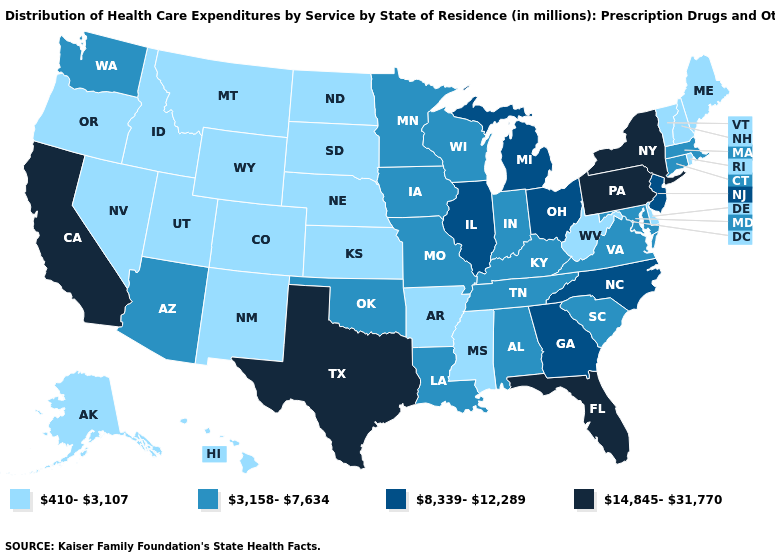Does Pennsylvania have a higher value than Alaska?
Quick response, please. Yes. Does Nevada have the same value as Kansas?
Write a very short answer. Yes. Among the states that border Idaho , which have the highest value?
Short answer required. Washington. What is the lowest value in states that border Vermont?
Short answer required. 410-3,107. Name the states that have a value in the range 3,158-7,634?
Concise answer only. Alabama, Arizona, Connecticut, Indiana, Iowa, Kentucky, Louisiana, Maryland, Massachusetts, Minnesota, Missouri, Oklahoma, South Carolina, Tennessee, Virginia, Washington, Wisconsin. Name the states that have a value in the range 410-3,107?
Quick response, please. Alaska, Arkansas, Colorado, Delaware, Hawaii, Idaho, Kansas, Maine, Mississippi, Montana, Nebraska, Nevada, New Hampshire, New Mexico, North Dakota, Oregon, Rhode Island, South Dakota, Utah, Vermont, West Virginia, Wyoming. Name the states that have a value in the range 3,158-7,634?
Keep it brief. Alabama, Arizona, Connecticut, Indiana, Iowa, Kentucky, Louisiana, Maryland, Massachusetts, Minnesota, Missouri, Oklahoma, South Carolina, Tennessee, Virginia, Washington, Wisconsin. Does the first symbol in the legend represent the smallest category?
Be succinct. Yes. What is the value of North Carolina?
Concise answer only. 8,339-12,289. Is the legend a continuous bar?
Short answer required. No. What is the value of Maine?
Give a very brief answer. 410-3,107. Among the states that border Kentucky , which have the lowest value?
Give a very brief answer. West Virginia. Does Illinois have a lower value than Texas?
Quick response, please. Yes. Does Michigan have a higher value than Louisiana?
Keep it brief. Yes. What is the highest value in the South ?
Write a very short answer. 14,845-31,770. 